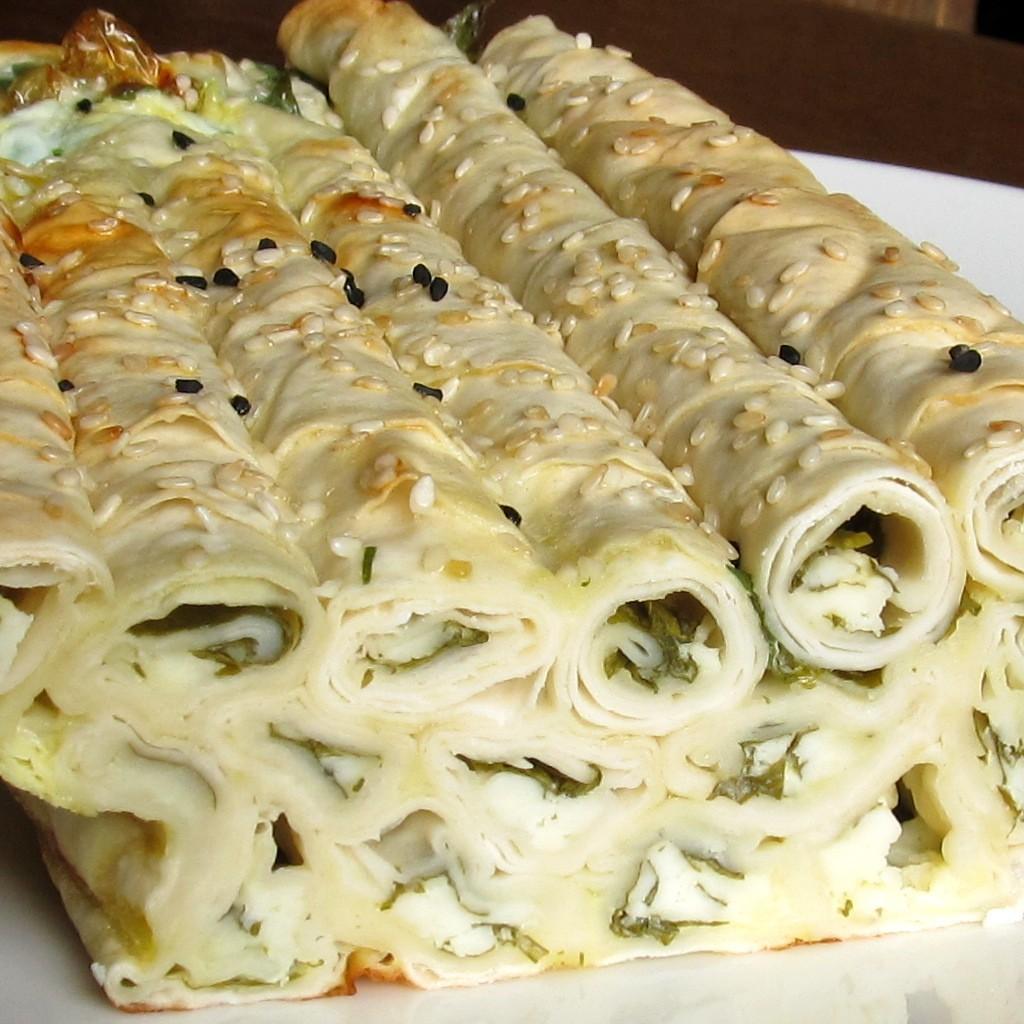How would you summarize this image in a sentence or two? In this image we can see food in a plate which is on the platform. 